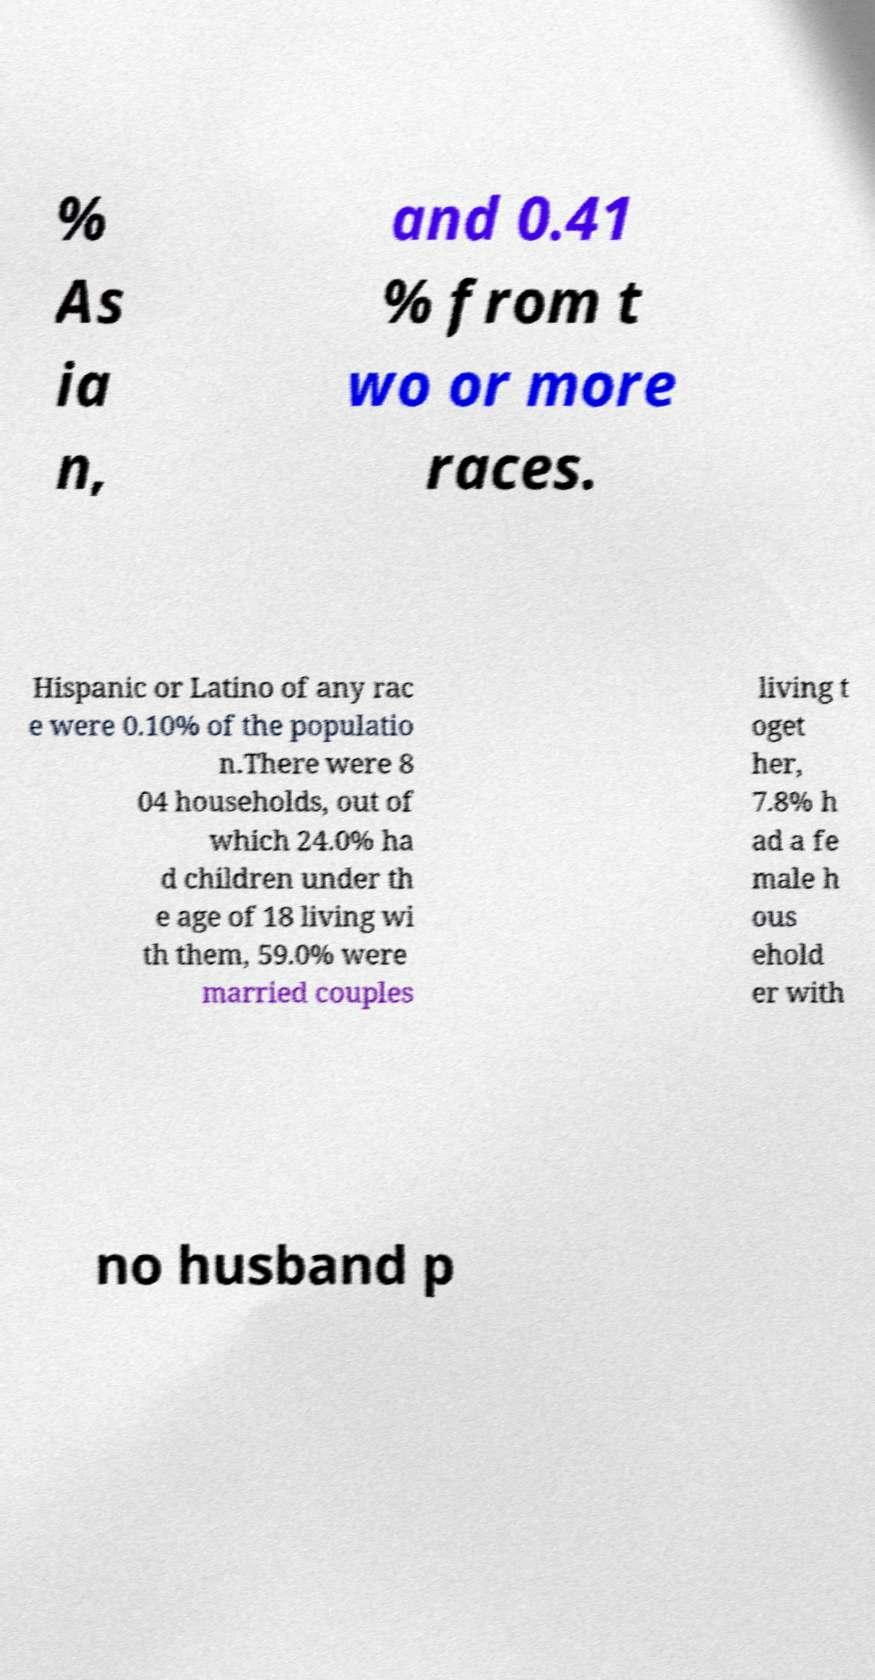Can you accurately transcribe the text from the provided image for me? % As ia n, and 0.41 % from t wo or more races. Hispanic or Latino of any rac e were 0.10% of the populatio n.There were 8 04 households, out of which 24.0% ha d children under th e age of 18 living wi th them, 59.0% were married couples living t oget her, 7.8% h ad a fe male h ous ehold er with no husband p 